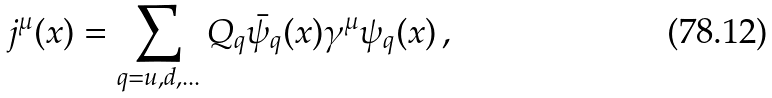<formula> <loc_0><loc_0><loc_500><loc_500>j ^ { \mu } ( x ) = \sum _ { q = u , d , \dots } Q _ { q } \bar { \psi } _ { q } ( x ) \gamma ^ { \mu } \psi _ { q } ( x ) \, ,</formula> 